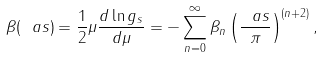Convert formula to latex. <formula><loc_0><loc_0><loc_500><loc_500>\beta ( \ a s ) = \frac { 1 } { 2 } \mu \frac { d \ln g _ { s } } { d \mu } = - \sum _ { n = 0 } ^ { \infty } \beta _ { n } \left ( \frac { \ a s } { \pi } \right ) ^ { ( n + 2 ) } ,</formula> 